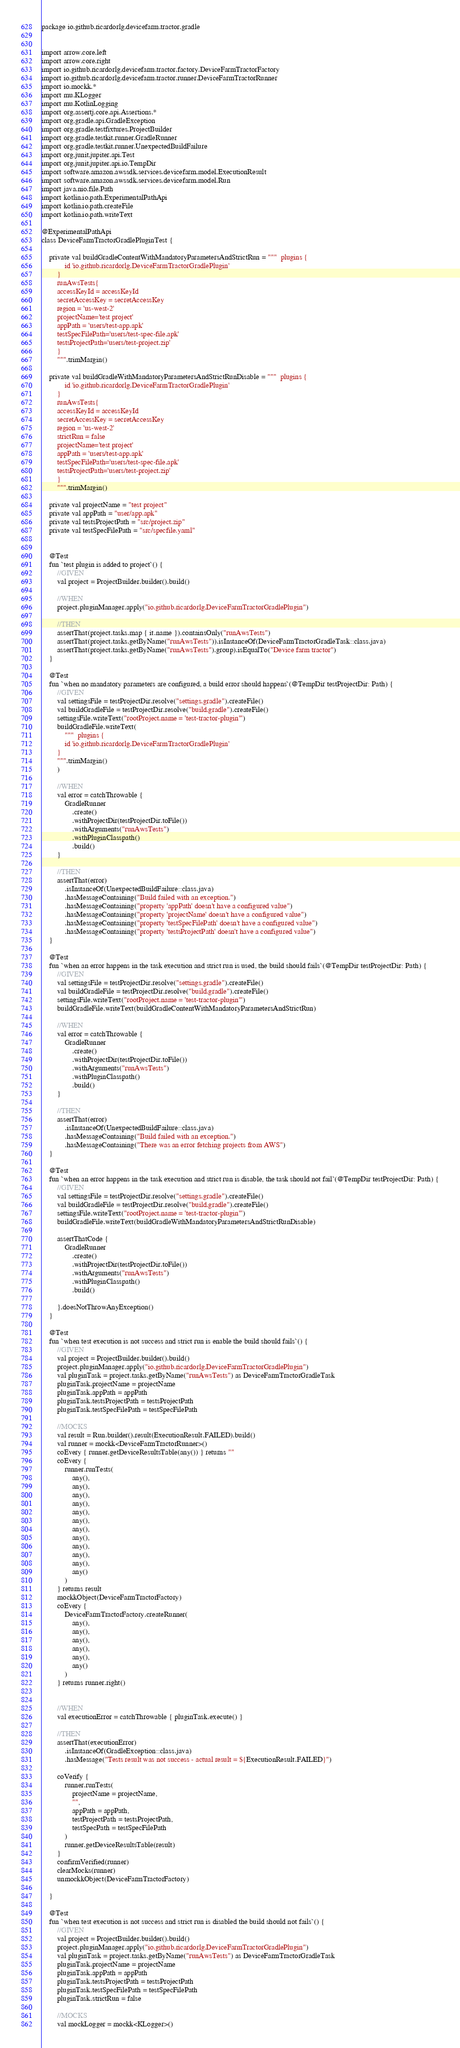Convert code to text. <code><loc_0><loc_0><loc_500><loc_500><_Kotlin_>package io.github.ricardorlg.devicefarm.tractor.gradle


import arrow.core.left
import arrow.core.right
import io.github.ricardorlg.devicefarm.tractor.factory.DeviceFarmTractorFactory
import io.github.ricardorlg.devicefarm.tractor.runner.DeviceFarmTractorRunner
import io.mockk.*
import mu.KLogger
import mu.KotlinLogging
import org.assertj.core.api.Assertions.*
import org.gradle.api.GradleException
import org.gradle.testfixtures.ProjectBuilder
import org.gradle.testkit.runner.GradleRunner
import org.gradle.testkit.runner.UnexpectedBuildFailure
import org.junit.jupiter.api.Test
import org.junit.jupiter.api.io.TempDir
import software.amazon.awssdk.services.devicefarm.model.ExecutionResult
import software.amazon.awssdk.services.devicefarm.model.Run
import java.nio.file.Path
import kotlin.io.path.ExperimentalPathApi
import kotlin.io.path.createFile
import kotlin.io.path.writeText

@ExperimentalPathApi
class DeviceFarmTractorGradlePluginTest {

    private val buildGradleContentWithMandatoryParametersAndStrictRun = """  plugins {
            id 'io.github.ricardorlg.DeviceFarmTractorGradlePlugin'
        }
        runAwsTests{
        accessKeyId = accessKeyId
        secretAccessKey = secretAccessKey
        region = 'us-west-2'
        projectName='test project'
        appPath = 'users/test-app.apk'
        testSpecFilePath='users/test-spec-file.apk'
        testsProjectPath='users/test-project.zip'
        }
        """.trimMargin()

    private val buildGradleWithMandatoryParametersAndStrictRunDisable = """  plugins {
            id 'io.github.ricardorlg.DeviceFarmTractorGradlePlugin'
        }
        runAwsTests{
        accessKeyId = accessKeyId
        secretAccessKey = secretAccessKey
        region = 'us-west-2'
        strictRun = false
        projectName='test project'
        appPath = 'users/test-app.apk'
        testSpecFilePath='users/test-spec-file.apk'
        testsProjectPath='users/test-project.zip'
        }
        """.trimMargin()

    private val projectName = "test project"
    private val appPath = "user/app.apk"
    private val testsProjectPath = "src/project.zip"
    private val testSpecFilePath = "src/specfile.yaml"


    @Test
    fun `test plugin is added to project`() {
        //GIVEN
        val project = ProjectBuilder.builder().build()

        //WHEN
        project.pluginManager.apply("io.github.ricardorlg.DeviceFarmTractorGradlePlugin")

        //THEN
        assertThat(project.tasks.map { it.name }).containsOnly("runAwsTests")
        assertThat(project.tasks.getByName("runAwsTests")).isInstanceOf(DeviceFarmTractorGradleTask::class.java)
        assertThat(project.tasks.getByName("runAwsTests").group).isEqualTo("Device farm tractor")
    }

    @Test
    fun `when no mandatory parameters are configured, a build error should happens`(@TempDir testProjectDir: Path) {
        //GIVEN
        val settingsFile = testProjectDir.resolve("settings.gradle").createFile()
        val buildGradleFile = testProjectDir.resolve("build.gradle").createFile()
        settingsFile.writeText("rootProject.name = 'test-tractor-plugin'")
        buildGradleFile.writeText(
            """  plugins {
            id 'io.github.ricardorlg.DeviceFarmTractorGradlePlugin'
        }
        """.trimMargin()
        )

        //WHEN
        val error = catchThrowable {
            GradleRunner
                .create()
                .withProjectDir(testProjectDir.toFile())
                .withArguments("runAwsTests")
                .withPluginClasspath()
                .build()
        }

        //THEN
        assertThat(error)
            .isInstanceOf(UnexpectedBuildFailure::class.java)
            .hasMessageContaining("Build failed with an exception.")
            .hasMessageContaining("property 'appPath' doesn't have a configured value")
            .hasMessageContaining("property 'projectName' doesn't have a configured value")
            .hasMessageContaining("property 'testSpecFilePath' doesn't have a configured value")
            .hasMessageContaining("property 'testsProjectPath' doesn't have a configured value")
    }

    @Test
    fun `when an error happens in the task execution and strict run is used, the build should fails`(@TempDir testProjectDir: Path) {
        //GIVEN
        val settingsFile = testProjectDir.resolve("settings.gradle").createFile()
        val buildGradleFile = testProjectDir.resolve("build.gradle").createFile()
        settingsFile.writeText("rootProject.name = 'test-tractor-plugin'")
        buildGradleFile.writeText(buildGradleContentWithMandatoryParametersAndStrictRun)

        //WHEN
        val error = catchThrowable {
            GradleRunner
                .create()
                .withProjectDir(testProjectDir.toFile())
                .withArguments("runAwsTests")
                .withPluginClasspath()
                .build()
        }

        //THEN
        assertThat(error)
            .isInstanceOf(UnexpectedBuildFailure::class.java)
            .hasMessageContaining("Build failed with an exception.")
            .hasMessageContaining("There was an error fetching projects from AWS")
    }

    @Test
    fun `when an error happens in the task execution and strict run is disable, the task should not fail`(@TempDir testProjectDir: Path) {
        //GIVEN
        val settingsFile = testProjectDir.resolve("settings.gradle").createFile()
        val buildGradleFile = testProjectDir.resolve("build.gradle").createFile()
        settingsFile.writeText("rootProject.name = 'test-tractor-plugin'")
        buildGradleFile.writeText(buildGradleWithMandatoryParametersAndStrictRunDisable)

        assertThatCode {
            GradleRunner
                .create()
                .withProjectDir(testProjectDir.toFile())
                .withArguments("runAwsTests")
                .withPluginClasspath()
                .build()

        }.doesNotThrowAnyException()
    }

    @Test
    fun `when test execution is not success and strict run is enable the build should fails`() {
        //GIVEN
        val project = ProjectBuilder.builder().build()
        project.pluginManager.apply("io.github.ricardorlg.DeviceFarmTractorGradlePlugin")
        val pluginTask = project.tasks.getByName("runAwsTests") as DeviceFarmTractorGradleTask
        pluginTask.projectName = projectName
        pluginTask.appPath = appPath
        pluginTask.testsProjectPath = testsProjectPath
        pluginTask.testSpecFilePath = testSpecFilePath

        //MOCKS
        val result = Run.builder().result(ExecutionResult.FAILED).build()
        val runner = mockk<DeviceFarmTractorRunner>()
        coEvery { runner.getDeviceResultsTable(any()) } returns ""
        coEvery {
            runner.runTests(
                any(),
                any(),
                any(),
                any(),
                any(),
                any(),
                any(),
                any(),
                any(),
                any(),
                any(),
                any()
            )
        } returns result
        mockkObject(DeviceFarmTractorFactory)
        coEvery {
            DeviceFarmTractorFactory.createRunner(
                any(),
                any(),
                any(),
                any(),
                any(),
                any()
            )
        } returns runner.right()


        //WHEN
        val executionError = catchThrowable { pluginTask.execute() }

        //THEN
        assertThat(executionError)
            .isInstanceOf(GradleException::class.java)
            .hasMessage("Tests result was not success - actual result = ${ExecutionResult.FAILED}")

        coVerify {
            runner.runTests(
                projectName = projectName,
                "",
                appPath = appPath,
                testProjectPath = testsProjectPath,
                testSpecPath = testSpecFilePath
            )
            runner.getDeviceResultsTable(result)
        }
        confirmVerified(runner)
        clearMocks(runner)
        unmockkObject(DeviceFarmTractorFactory)

    }

    @Test
    fun `when test execution is not success and strict run is disabled the build should not fails`() {
        //GIVEN
        val project = ProjectBuilder.builder().build()
        project.pluginManager.apply("io.github.ricardorlg.DeviceFarmTractorGradlePlugin")
        val pluginTask = project.tasks.getByName("runAwsTests") as DeviceFarmTractorGradleTask
        pluginTask.projectName = projectName
        pluginTask.appPath = appPath
        pluginTask.testsProjectPath = testsProjectPath
        pluginTask.testSpecFilePath = testSpecFilePath
        pluginTask.strictRun = false

        //MOCKS
        val mockLogger = mockk<KLogger>()</code> 